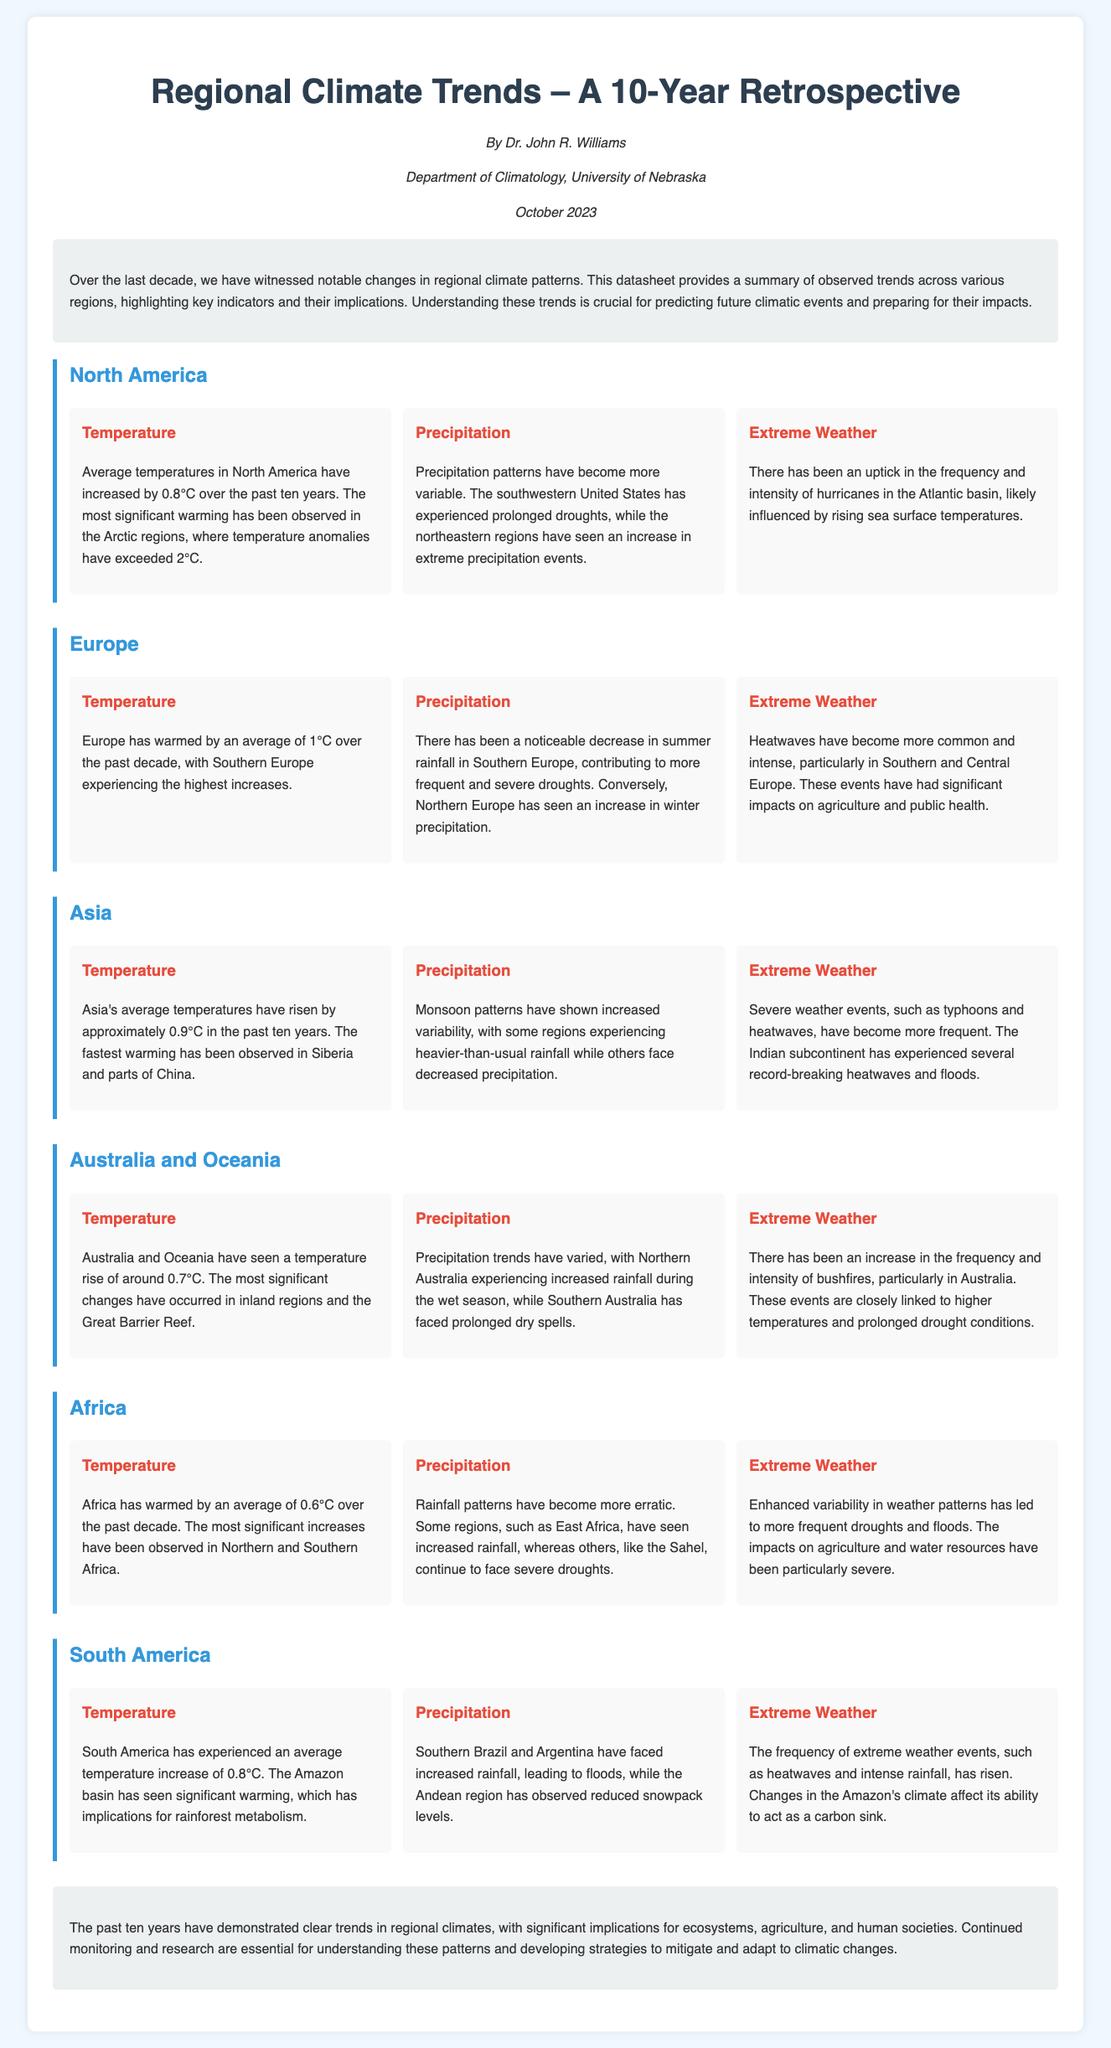what is the average temperature increase in North America over the past decade? The average temperature increase in North America is stated in the section on temperature in North America.
Answer: 0.8°C which region experienced a 1°C warming over the past decade? The section on temperature in Europe specifies that it warmed by 1°C.
Answer: Europe what are the two contrasting precipitation patterns observed in Southern and Northern Europe? The precipitation section in Europe indicates that Southern Europe has decreased summer rainfall while Northern Europe has increased winter precipitation.
Answer: Decreased summer rainfall; increased winter precipitation how much has Africa's average temperature increased in the last ten years? The temperature section for Africa notes that it has warmed by 0.6°C in the last decade.
Answer: 0.6°C which region has observed increased rainfall during the wet season? The precipitation section for Australia and Oceania indicates that Northern Australia has experienced increased rainfall during the wet season.
Answer: Northern Australia what extreme weather event has become more common and intense in Southern and Central Europe? The extreme weather section for Europe specifies that heatwaves have become more common and intense.
Answer: Heatwaves what climatic event has been influenced by rising sea surface temperatures in North America? The extreme weather section in North America mentions hurricanes influenced by rising sea surface temperatures.
Answer: Hurricanes what significant environmental issue is linked to increased temperatures and prolonged drought conditions in Australia? The extreme weather section for Australia cites the increase in the frequency and intensity of bushfires linked to those conditions.
Answer: Bushfires what extreme weather phenomenon has been recorded in the Indian subcontinent? The section on extreme weather for Asia states that the Indian subcontinent has experienced record-breaking heatwaves and floods.
Answer: Heatwaves and floods 